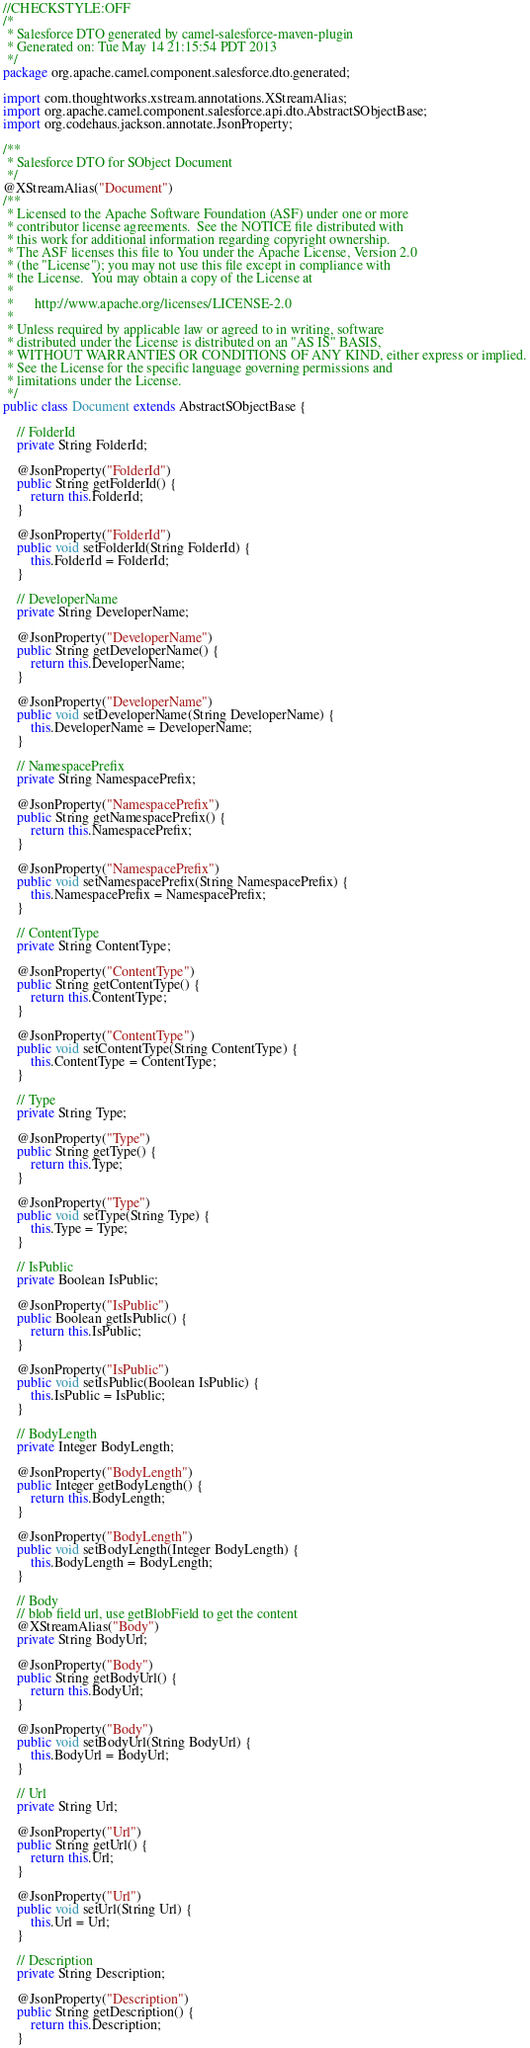Convert code to text. <code><loc_0><loc_0><loc_500><loc_500><_Java_>//CHECKSTYLE:OFF
/*
 * Salesforce DTO generated by camel-salesforce-maven-plugin
 * Generated on: Tue May 14 21:15:54 PDT 2013
 */
package org.apache.camel.component.salesforce.dto.generated;

import com.thoughtworks.xstream.annotations.XStreamAlias;
import org.apache.camel.component.salesforce.api.dto.AbstractSObjectBase;
import org.codehaus.jackson.annotate.JsonProperty;

/**
 * Salesforce DTO for SObject Document
 */
@XStreamAlias("Document")
/**
 * Licensed to the Apache Software Foundation (ASF) under one or more
 * contributor license agreements.  See the NOTICE file distributed with
 * this work for additional information regarding copyright ownership.
 * The ASF licenses this file to You under the Apache License, Version 2.0
 * (the "License"); you may not use this file except in compliance with
 * the License.  You may obtain a copy of the License at
 *
 *      http://www.apache.org/licenses/LICENSE-2.0
 *
 * Unless required by applicable law or agreed to in writing, software
 * distributed under the License is distributed on an "AS IS" BASIS,
 * WITHOUT WARRANTIES OR CONDITIONS OF ANY KIND, either express or implied.
 * See the License for the specific language governing permissions and
 * limitations under the License.
 */
public class Document extends AbstractSObjectBase {

    // FolderId
    private String FolderId;

    @JsonProperty("FolderId")
    public String getFolderId() {
        return this.FolderId;
    }

    @JsonProperty("FolderId")
    public void setFolderId(String FolderId) {
        this.FolderId = FolderId;
    }

    // DeveloperName
    private String DeveloperName;

    @JsonProperty("DeveloperName")
    public String getDeveloperName() {
        return this.DeveloperName;
    }

    @JsonProperty("DeveloperName")
    public void setDeveloperName(String DeveloperName) {
        this.DeveloperName = DeveloperName;
    }

    // NamespacePrefix
    private String NamespacePrefix;

    @JsonProperty("NamespacePrefix")
    public String getNamespacePrefix() {
        return this.NamespacePrefix;
    }

    @JsonProperty("NamespacePrefix")
    public void setNamespacePrefix(String NamespacePrefix) {
        this.NamespacePrefix = NamespacePrefix;
    }

    // ContentType
    private String ContentType;

    @JsonProperty("ContentType")
    public String getContentType() {
        return this.ContentType;
    }

    @JsonProperty("ContentType")
    public void setContentType(String ContentType) {
        this.ContentType = ContentType;
    }

    // Type
    private String Type;

    @JsonProperty("Type")
    public String getType() {
        return this.Type;
    }

    @JsonProperty("Type")
    public void setType(String Type) {
        this.Type = Type;
    }

    // IsPublic
    private Boolean IsPublic;

    @JsonProperty("IsPublic")
    public Boolean getIsPublic() {
        return this.IsPublic;
    }

    @JsonProperty("IsPublic")
    public void setIsPublic(Boolean IsPublic) {
        this.IsPublic = IsPublic;
    }

    // BodyLength
    private Integer BodyLength;

    @JsonProperty("BodyLength")
    public Integer getBodyLength() {
        return this.BodyLength;
    }

    @JsonProperty("BodyLength")
    public void setBodyLength(Integer BodyLength) {
        this.BodyLength = BodyLength;
    }

    // Body
    // blob field url, use getBlobField to get the content
    @XStreamAlias("Body")
    private String BodyUrl;

    @JsonProperty("Body")
    public String getBodyUrl() {
        return this.BodyUrl;
    }

    @JsonProperty("Body")
    public void setBodyUrl(String BodyUrl) {
        this.BodyUrl = BodyUrl;
    }

    // Url
    private String Url;

    @JsonProperty("Url")
    public String getUrl() {
        return this.Url;
    }

    @JsonProperty("Url")
    public void setUrl(String Url) {
        this.Url = Url;
    }

    // Description
    private String Description;

    @JsonProperty("Description")
    public String getDescription() {
        return this.Description;
    }
</code> 